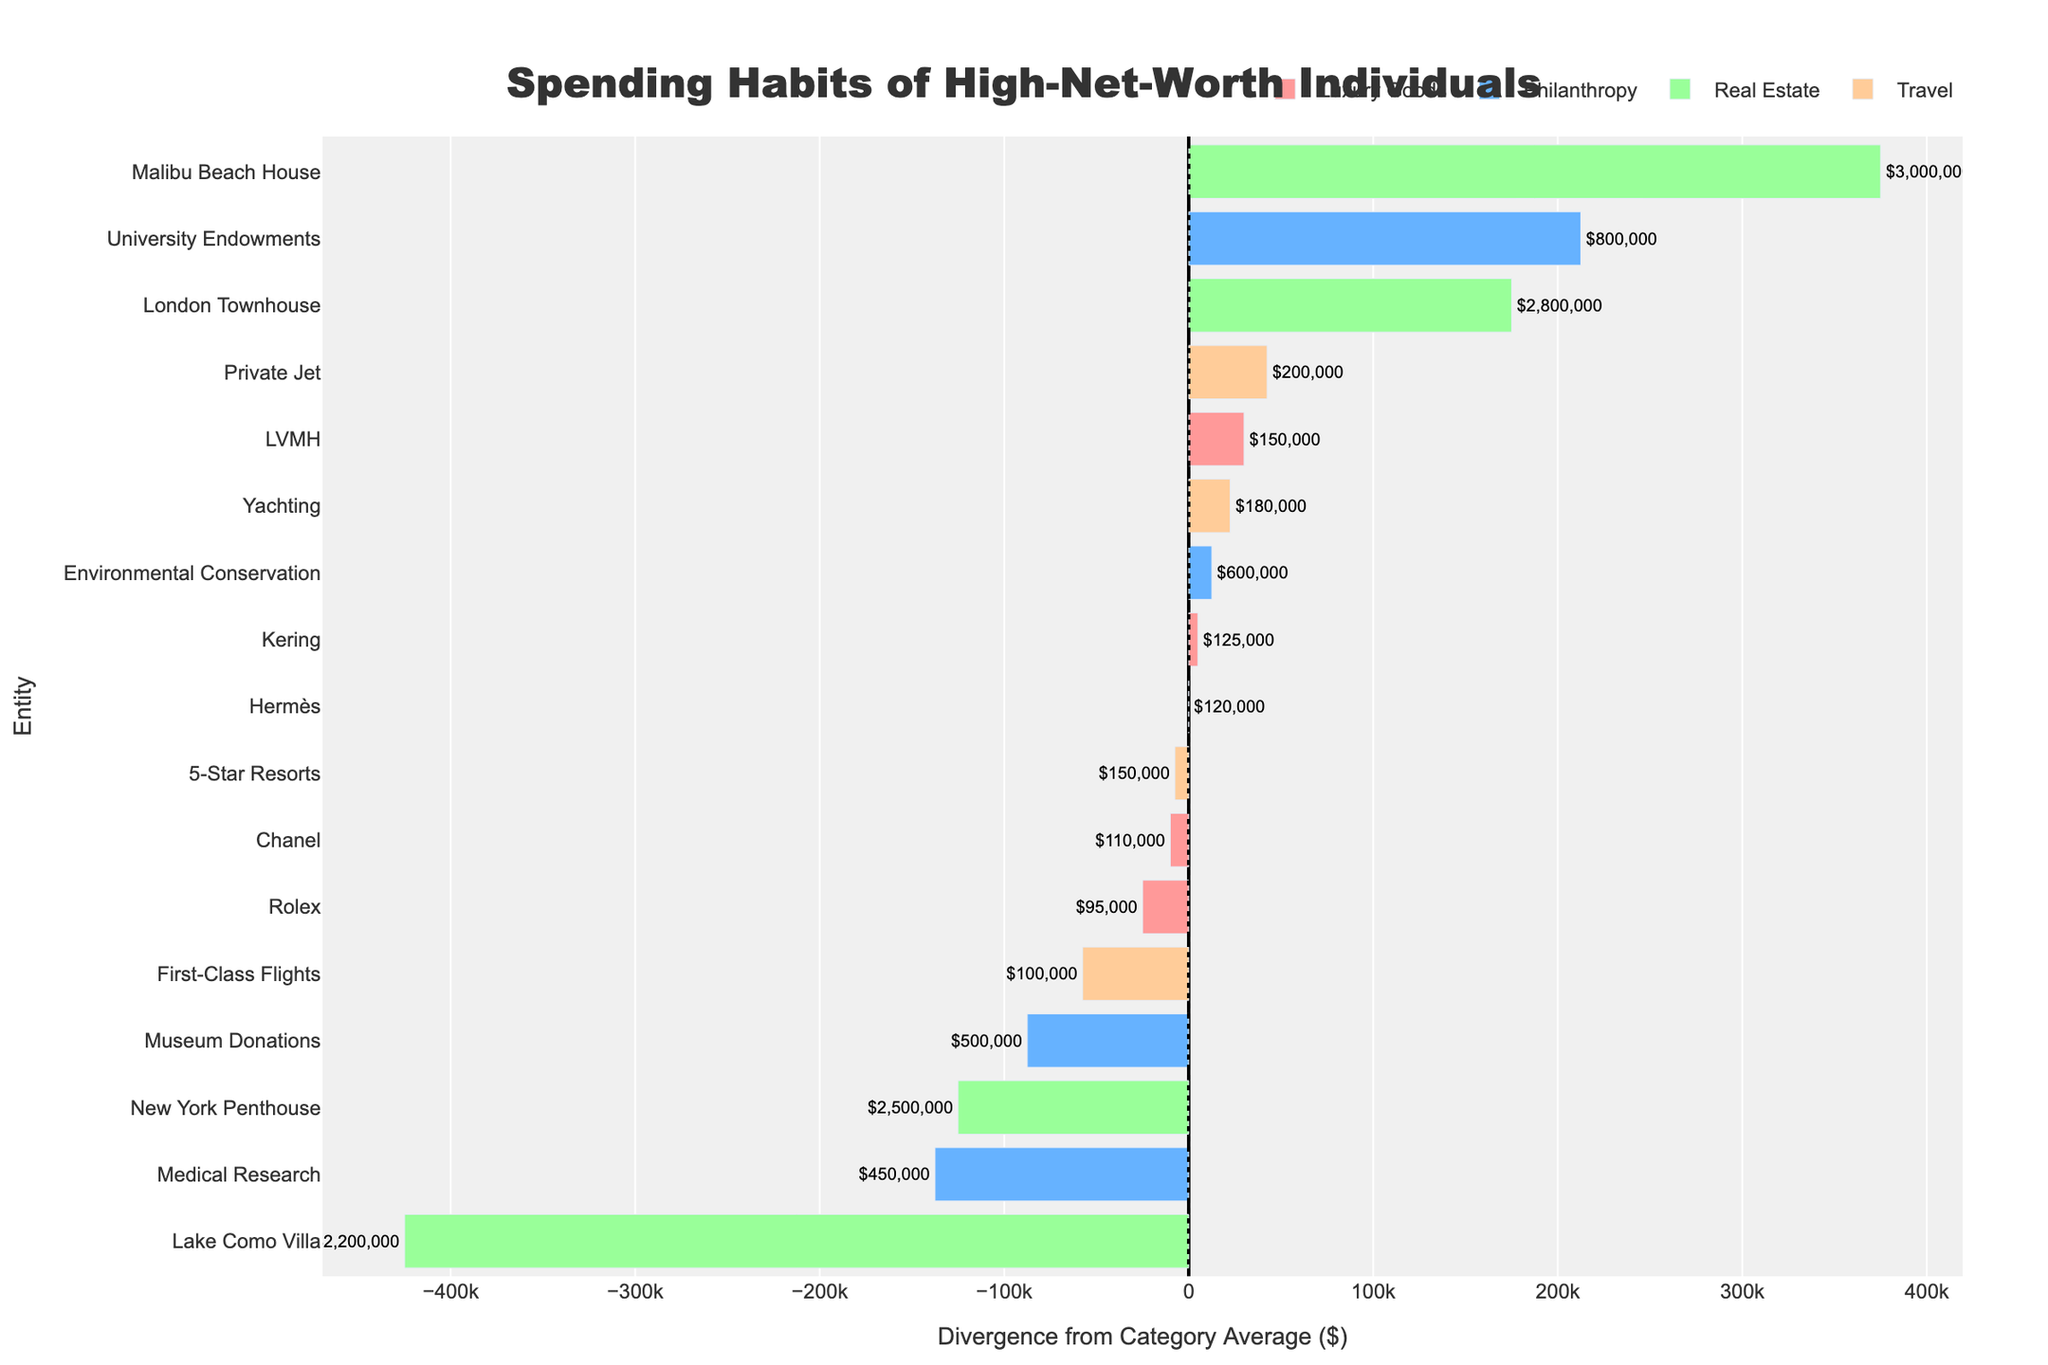What's the average spending in the Luxury Goods category? Calculate the total spending on Luxury Goods by summing up the amounts: 150,000 + 125,000 + 110,000 + 95,000 + 120,000 = 600,000. There are 5 entities in this category, so the average is 600,000 / 5 = 120,000
Answer: 120,000 Which entity has the highest divergence from the category average in Real Estate? First, find the average spending in Real Estate: (2,500,000 + 3,000,000 + 2,200,000 + 2,800,000) / 4 = 2,625,000. The divergences are: NY Penthouse(-125,000), Malibu Beach House(+375,000), Lake Como Villa(-425,000), London Townhouse(+175,000). The highest divergence is Malibu Beach House with 375,000
Answer: Malibu Beach House Which category shows the least average spending, and what is the category average? Calculate the average spending for each category: Luxury Goods (600,000/5 = 120,000), Travel (630,000/4 = 157,500), Real Estate (10,500,000/4 = 2,625,000), Philanthropy (2,350,000/4 = 587,500). The least average spending is in the Luxury Goods category
Answer: Luxury Goods, 120,000 Among all the travel entities, which one has the closest spending to the category average? First, find the average spending in Travel: (200,000 + 100,000 + 150,000 + 180,000) / 4 = 157,500. Calculate the absolute differences: Private Jet (42,500), First-Class Flights (57,500), 5-Star Resorts (7,500), Yachting (22,500). The closest is 5-Star Resorts with a difference of 7,500
Answer: 5-Star Resorts Which philanthropy entity has the lowest spending, and by how much is it below the category average? Calculate the average spending in Philanthropy: (500,000 + 800,000 + 450,000 + 600,000) / 4 = 587,500. The spending amounts are: Museum Donations (500,000), University Endowments (800,000), Medical Research (450,000), Environmental Conservation (600,000). The lowest spending is Medical Research, which is 137,500 below the category average (587,500 - 450,000) = 137,500
Answer: Medical Research, 137,500 Which entity has the highest spending overall, and what is the spending amount? Looking at each entity's spending in the data: NY Penthouse (2,500,000), Malibu Beach House(3,000,000), Lake Como Villa (2,200,000), London Townhouse (2,800,000) ... Malibu Beach House has the highest spending at 3,000,000
Answer: Malibu Beach House, 3,000,000 In the Luxury Goods category, which entity has the smallest negative divergence, and what is the divergence amount? Calculate the average spending of Luxury Goods: 120,000. Calculate the divergence: LVMH +30,000, Kering +5,000, Chanel -10,000, Rolex -25,000, Hermès 0. The smallest negative divergence is Chanel with -10,000
Answer: Chanel, -10,000 Which category has the widest range in spending, and by how much does the highest spending exceed the lowest? Calculate the highest individual spending from each category: Luxury Goods (150,000), Travel (200,000), Real Estate (3,000,000), Philanthropy (800,000). Calculate the lowest in each: Luxury Goods (95,000), Travel (100,000), Real Estate (2,200,000), Philanthropy (450,000). The widest range at Real Estate 3,000,000-2,200,000 = 800,000
Answer: Real Estate, 800,000 